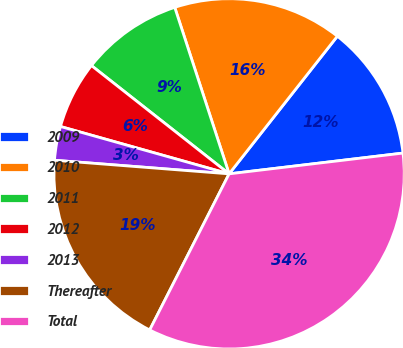<chart> <loc_0><loc_0><loc_500><loc_500><pie_chart><fcel>2009<fcel>2010<fcel>2011<fcel>2012<fcel>2013<fcel>Thereafter<fcel>Total<nl><fcel>12.5%<fcel>15.63%<fcel>9.37%<fcel>6.25%<fcel>3.12%<fcel>18.75%<fcel>34.38%<nl></chart> 